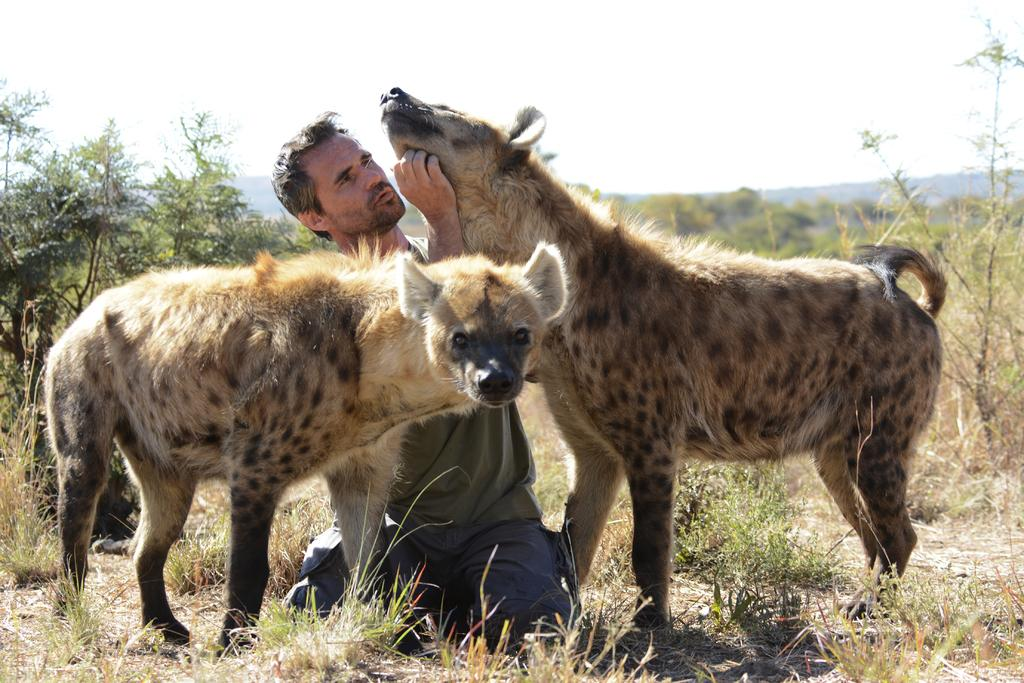What animals are present in the image? There are hyenas in the image. What is the man in the image doing? The man is seated and touching a hyena with his hand. What type of vegetation can be seen in the image? There are trees, plants, and grass in the image. What does the man desire from the hyena in the image? There is no indication in the image of what the man desires from the hyena, as the focus is on the man touching the hyena with his hand. 